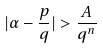Convert formula to latex. <formula><loc_0><loc_0><loc_500><loc_500>| \alpha - \frac { p } { q } | > \frac { A } { q ^ { n } }</formula> 